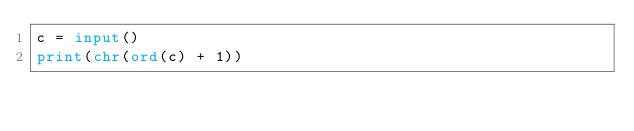<code> <loc_0><loc_0><loc_500><loc_500><_Python_>c = input()
print(chr(ord(c) + 1))</code> 